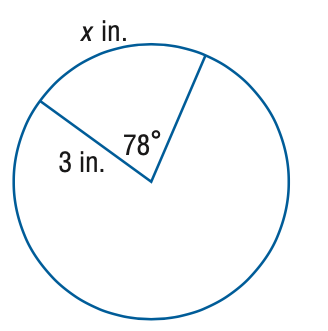Question: Find the value of x.
Choices:
A. 1.02
B. 2.04
C. 4.08
D. 8.17
Answer with the letter. Answer: C 